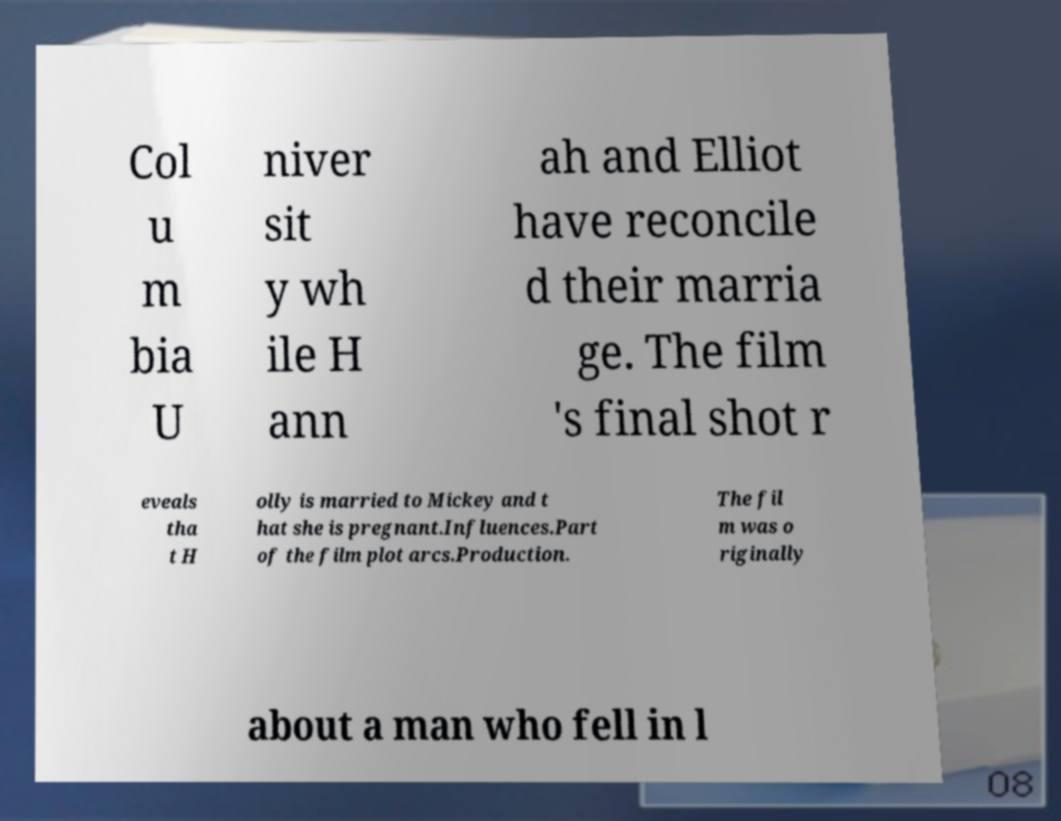Can you accurately transcribe the text from the provided image for me? Col u m bia U niver sit y wh ile H ann ah and Elliot have reconcile d their marria ge. The film 's final shot r eveals tha t H olly is married to Mickey and t hat she is pregnant.Influences.Part of the film plot arcs.Production. The fil m was o riginally about a man who fell in l 